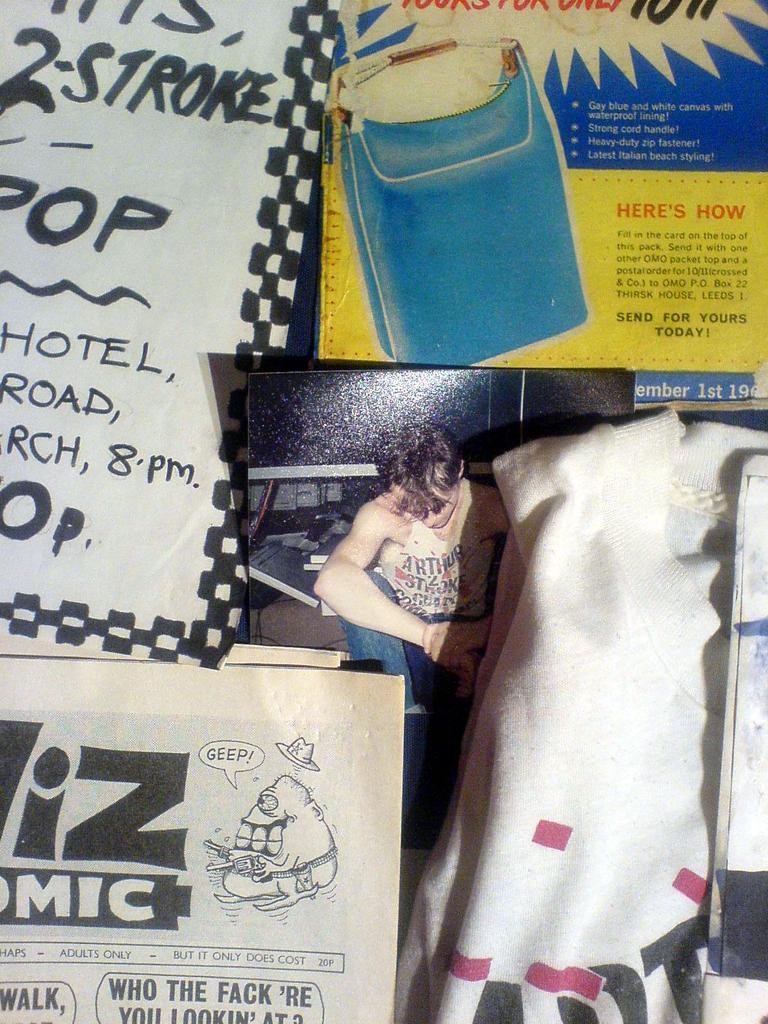What objects are present in the image that are made of wood or a similar material? There are boards in the image. What type of paper items can be seen in the image? There are papers in the image. What type of fabric item is visible in the image? There is a cloth in the image. What type of reaction can be seen from the potato in the image? There is no potato present in the image, so it is not possible to determine any reaction from a potato. Can you describe the grass in the image? There is no grass present in the image. 